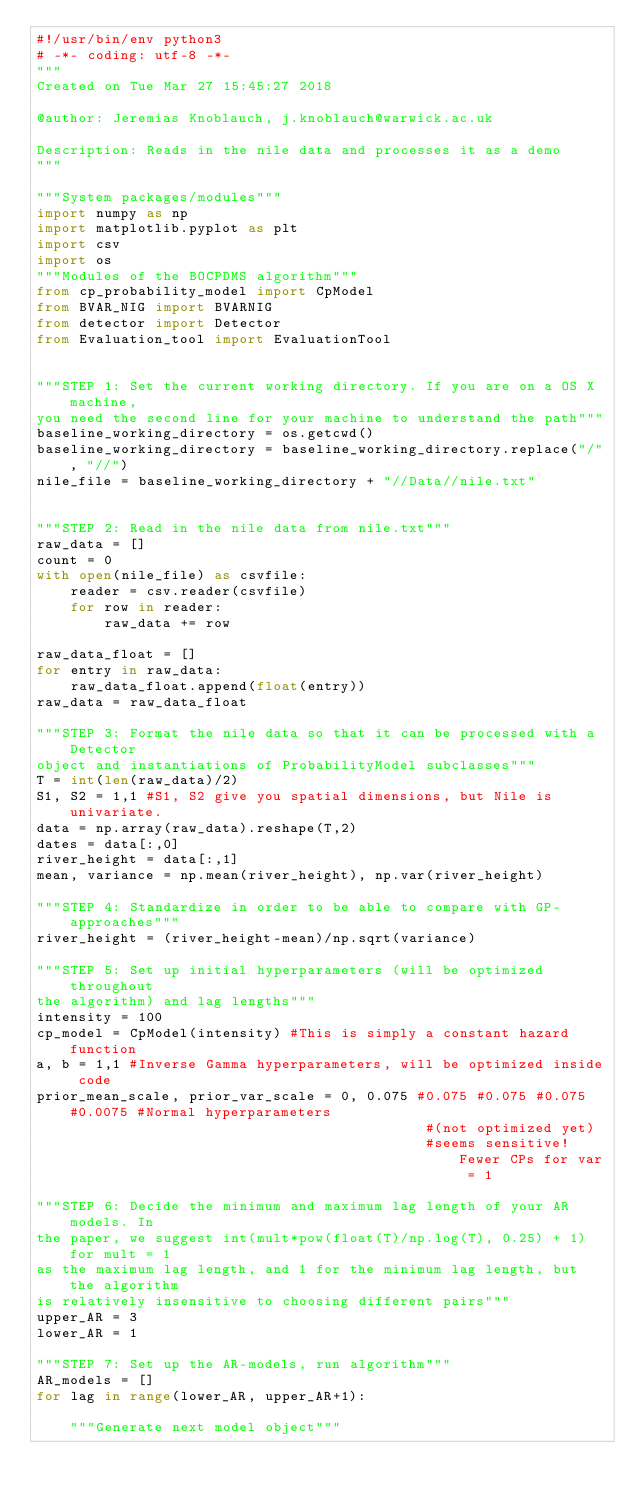<code> <loc_0><loc_0><loc_500><loc_500><_Python_>#!/usr/bin/env python3
# -*- coding: utf-8 -*-
"""
Created on Tue Mar 27 15:45:27 2018

@author: Jeremias Knoblauch, j.knoblauch@warwick.ac.uk

Description: Reads in the nile data and processes it as a demo
"""

"""System packages/modules"""
import numpy as np
import matplotlib.pyplot as plt
import csv
import os
"""Modules of the BOCPDMS algorithm"""
from cp_probability_model import CpModel
from BVAR_NIG import BVARNIG
from detector import Detector
from Evaluation_tool import EvaluationTool


"""STEP 1: Set the current working directory. If you are on a OS X machine,
you need the second line for your machine to understand the path"""
baseline_working_directory = os.getcwd()
baseline_working_directory = baseline_working_directory.replace("/", "//") 
nile_file = baseline_working_directory + "//Data//nile.txt"


"""STEP 2: Read in the nile data from nile.txt"""
raw_data = []
count = 0 
with open(nile_file) as csvfile:
    reader = csv.reader(csvfile)
    for row in reader:
        raw_data += row

raw_data_float = []
for entry in raw_data:
    raw_data_float.append(float(entry))
raw_data = raw_data_float

"""STEP 3: Format the nile data so that it can be processed with a Detector
object and instantiations of ProbabilityModel subclasses"""
T = int(len(raw_data)/2)
S1, S2 = 1,1 #S1, S2 give you spatial dimensions, but Nile is univariate.
data = np.array(raw_data).reshape(T,2)
dates = data[:,0]
river_height = data[:,1]
mean, variance = np.mean(river_height), np.var(river_height)

"""STEP 4: Standardize in order to be able to compare with GP-approaches"""
river_height = (river_height-mean)/np.sqrt(variance)

"""STEP 5: Set up initial hyperparameters (will be optimized throughout 
the algorithm) and lag lengths"""
intensity = 100
cp_model = CpModel(intensity) #This is simply a constant hazard function
a, b = 1,1 #Inverse Gamma hyperparameters, will be optimized inside code
prior_mean_scale, prior_var_scale = 0, 0.075 #0.075 #0.075 #0.075 #0.0075 #Normal hyperparameters 
                                              #(not optimized yet)
                                              #seems sensitive! Fewer CPs for var = 1

"""STEP 6: Decide the minimum and maximum lag length of your AR models. In 
the paper, we suggest int(mult*pow(float(T)/np.log(T), 0.25) + 1) for mult = 1
as the maximum lag length, and 1 for the minimum lag length, but the algorithm
is relatively insensitive to choosing different pairs"""
upper_AR = 3
lower_AR = 1 

"""STEP 7: Set up the AR-models, run algorithm"""
AR_models = []
for lag in range(lower_AR, upper_AR+1):
    
    """Generate next model object"""</code> 